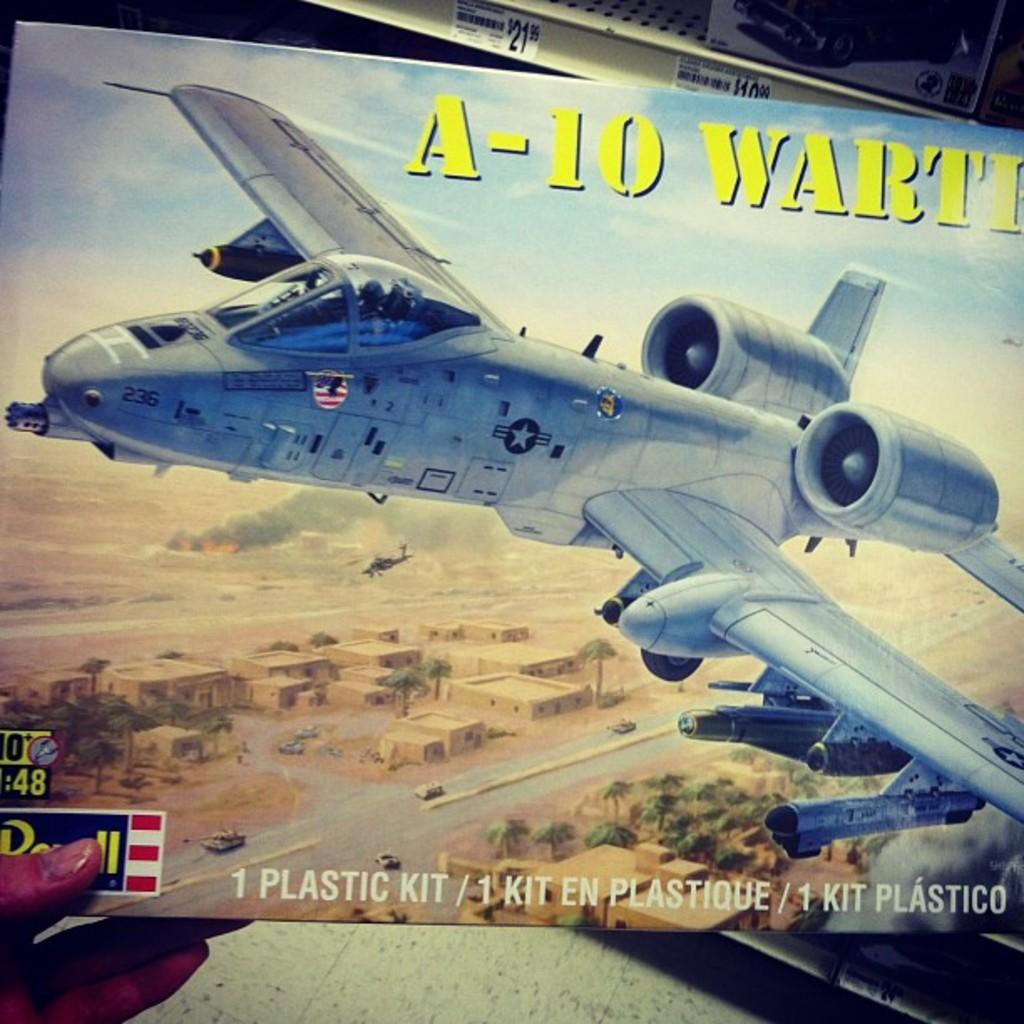<image>
Describe the image concisely. A plastic model airplane kit for an A-10 Warthog plane. 